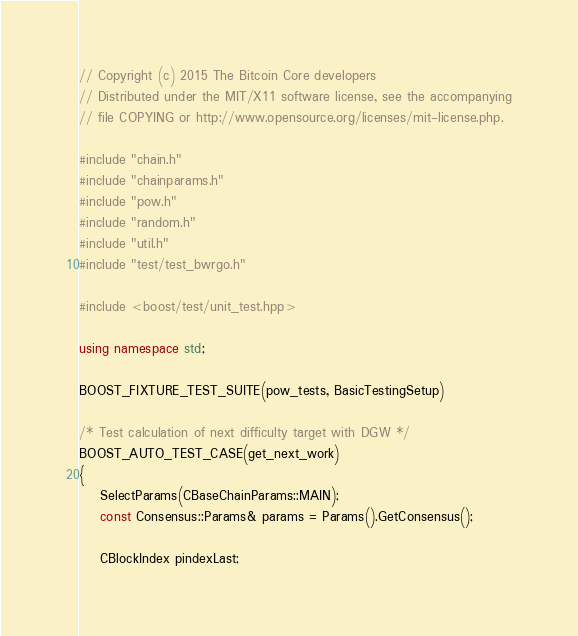<code> <loc_0><loc_0><loc_500><loc_500><_C++_>// Copyright (c) 2015 The Bitcoin Core developers
// Distributed under the MIT/X11 software license, see the accompanying
// file COPYING or http://www.opensource.org/licenses/mit-license.php.

#include "chain.h"
#include "chainparams.h"
#include "pow.h"
#include "random.h"
#include "util.h"
#include "test/test_bwrgo.h"

#include <boost/test/unit_test.hpp>

using namespace std;

BOOST_FIXTURE_TEST_SUITE(pow_tests, BasicTestingSetup)

/* Test calculation of next difficulty target with DGW */
BOOST_AUTO_TEST_CASE(get_next_work)
{
    SelectParams(CBaseChainParams::MAIN);
    const Consensus::Params& params = Params().GetConsensus();

    CBlockIndex pindexLast;</code> 